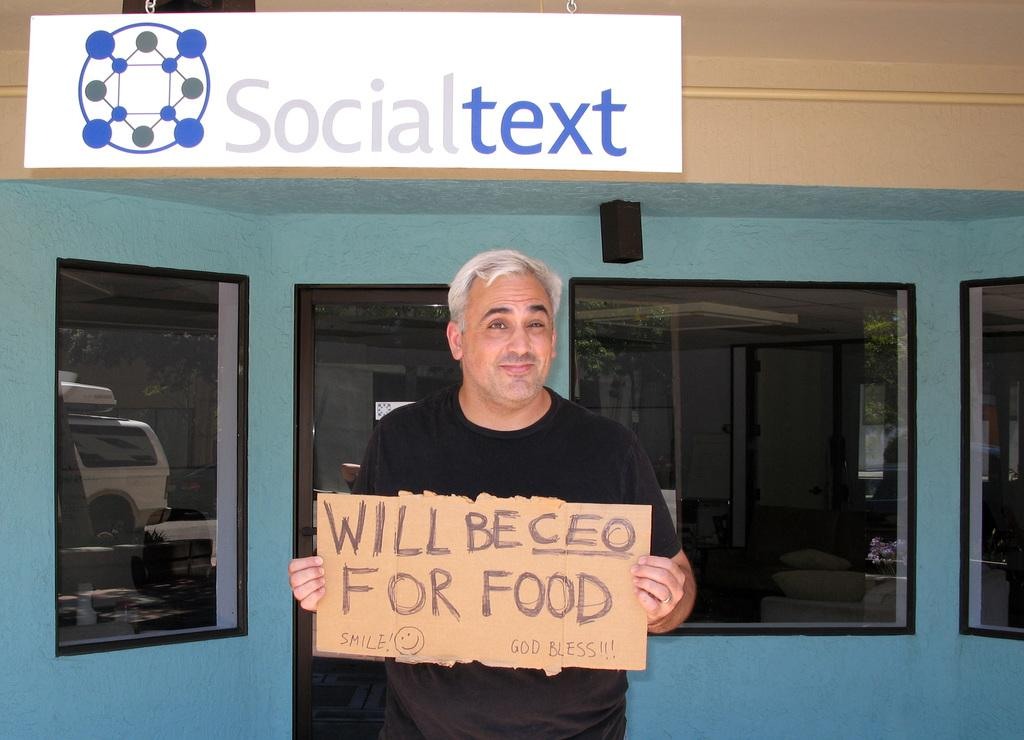What is the person in the image doing? The person is standing and holding a board in the image. What can be seen on the wall in the background of the image? There are glasses and windows on the wall in the background of the image. What is the board in front of the building used for? The purpose of the board in front of the building is not specified in the facts provided. What month is depicted on the thumb of the person in the image? There is no thumb or month mentioned in the image; the person is holding a board. 